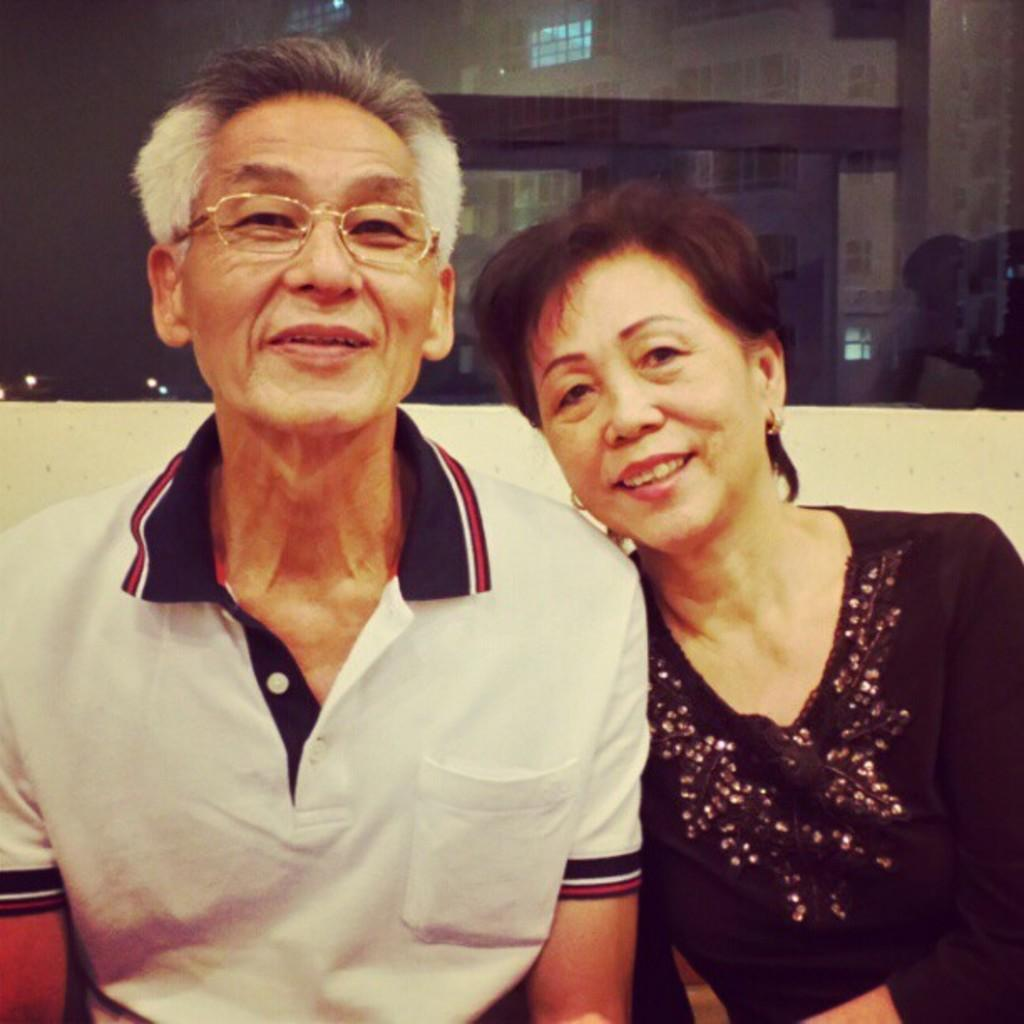How many people are present in the image? There are two people, a man and a woman, present in the image. What is the man wearing in the image? The man is wearing glasses (specs) in the image. What can be seen in the background of the image? There is a building with windows in the background of the image. What color is the man's tongue in the image? There is no mention of the man's tongue in the image, so we cannot determine its color. Who is the father of the woman in the image? The provided facts do not give any information about the family relationships of the people in the image, so we cannot determine the father of the woman. 